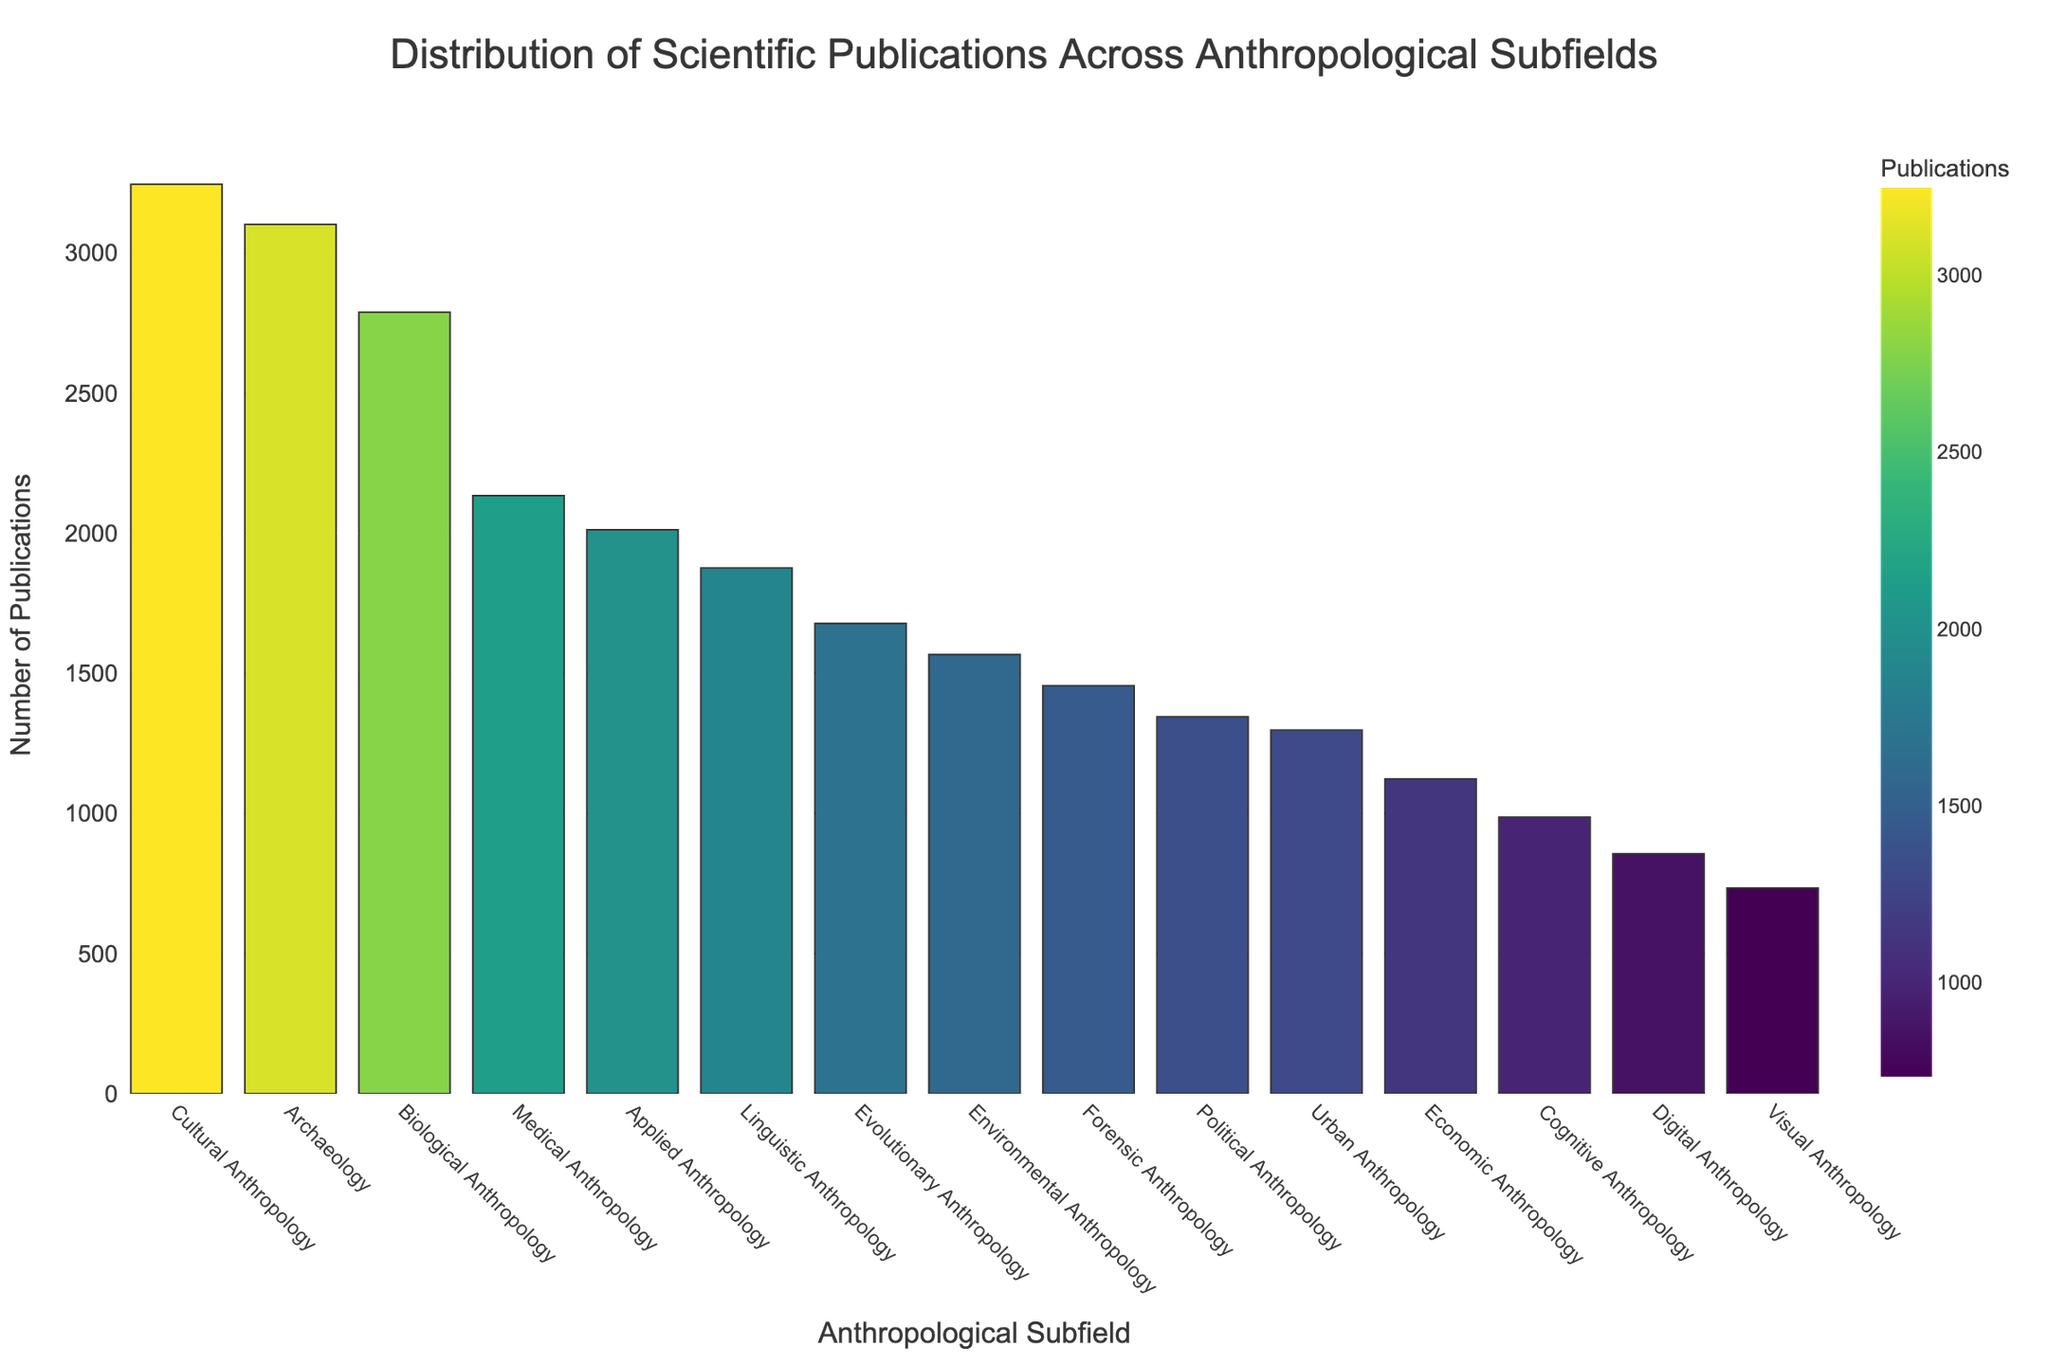How many more publications does Cultural Anthropology have compared to Environmental Anthropology? To find the difference, subtract the number of publications in Environmental Anthropology from those in Cultural Anthropology: 3245 - 1567 = 1678
Answer: 1678 Which subfield has the least number of publications? By looking at the height of the bars and sorting them, we see that Visual Anthropology has the shortest bar, indicating it has the least publications at 734
Answer: Visual Anthropology What is the total number of publications in the subfields of Medical Anthropology, Environmental Anthropology, and Urban Anthropology combined? To find the total, sum the number of publications in these three subfields: 2134 + 1567 + 1298 = 4999
Answer: 4999 Compare the number of publications in Cognitive Anthropology and Forensic Anthropology and identify which one has more publications. By comparing the heights of the bars, Forensic Anthropology (1456) has more publications than Cognitive Anthropology (987)
Answer: Forensic Anthropology What percentage of the total publications does Archaeology represent? First, calculate the total number of publications by summing all values: 3245 + 2789 + 1876 + 3102 + 2134 + 1567 + 1298 + 987 + 1456 + 856 + 1123 + 1345 + 734 + 1678 + 2012 = 28902. Then, find the percentage: (3102 / 28902) * 100 ≈ 10.73%
Answer: 10.73% Which subfield has the second highest number of publications? After Cultural Anthropology, Archaeology has the second highest publication count with 3102
Answer: Archaeology How does the publication count of Digital Anthropology compare to Economic Anthropology? Compare the heights of the bars: Digital Anthropology (856) has fewer publications than Economic Anthropology (1123)
Answer: Economic Anthropology If you combine the number of publications in Political Anthropology and Applied Anthropology, do they exceed those in Biological Anthropology? Sum the publications in Political and Applied Anthropology and compare: 1345 + 2012 = 3357, which is more than Biological Anthropology's 2789
Answer: Yes What's the average number of publications across all subfields? Sum all the publication numbers (28902) and divide by the number of subfields (15): 28902 / 15 ≈ 1926.8
Answer: 1926.8 